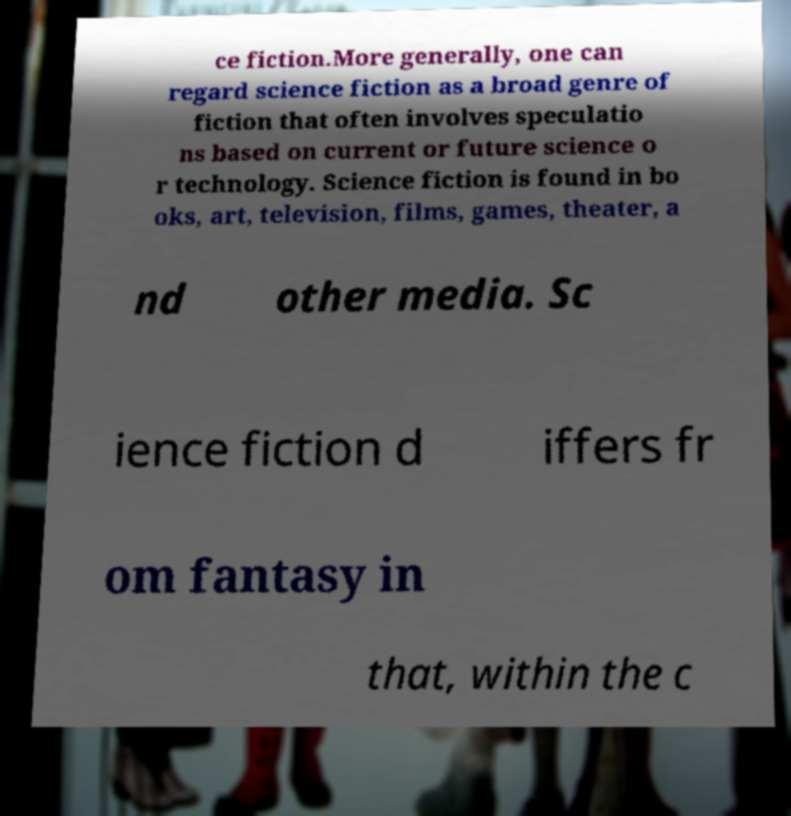There's text embedded in this image that I need extracted. Can you transcribe it verbatim? ce fiction.More generally, one can regard science fiction as a broad genre of fiction that often involves speculatio ns based on current or future science o r technology. Science fiction is found in bo oks, art, television, films, games, theater, a nd other media. Sc ience fiction d iffers fr om fantasy in that, within the c 